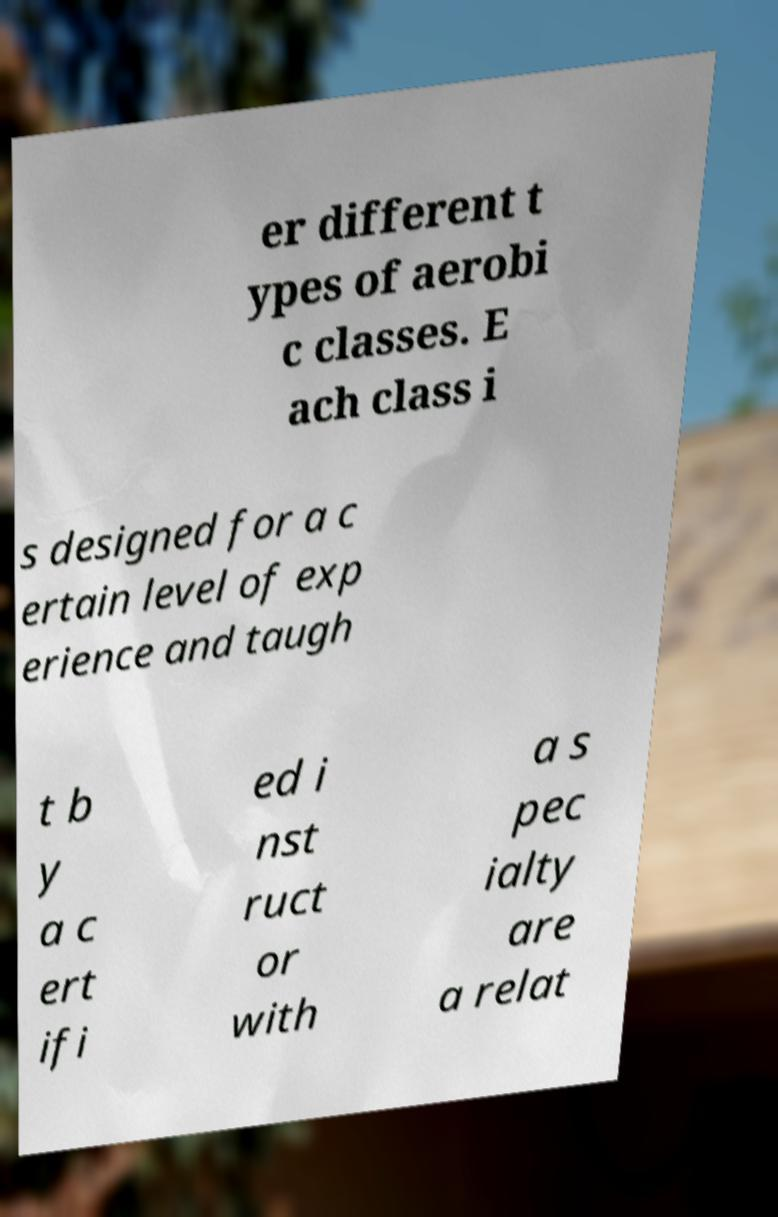Could you extract and type out the text from this image? er different t ypes of aerobi c classes. E ach class i s designed for a c ertain level of exp erience and taugh t b y a c ert ifi ed i nst ruct or with a s pec ialty are a relat 